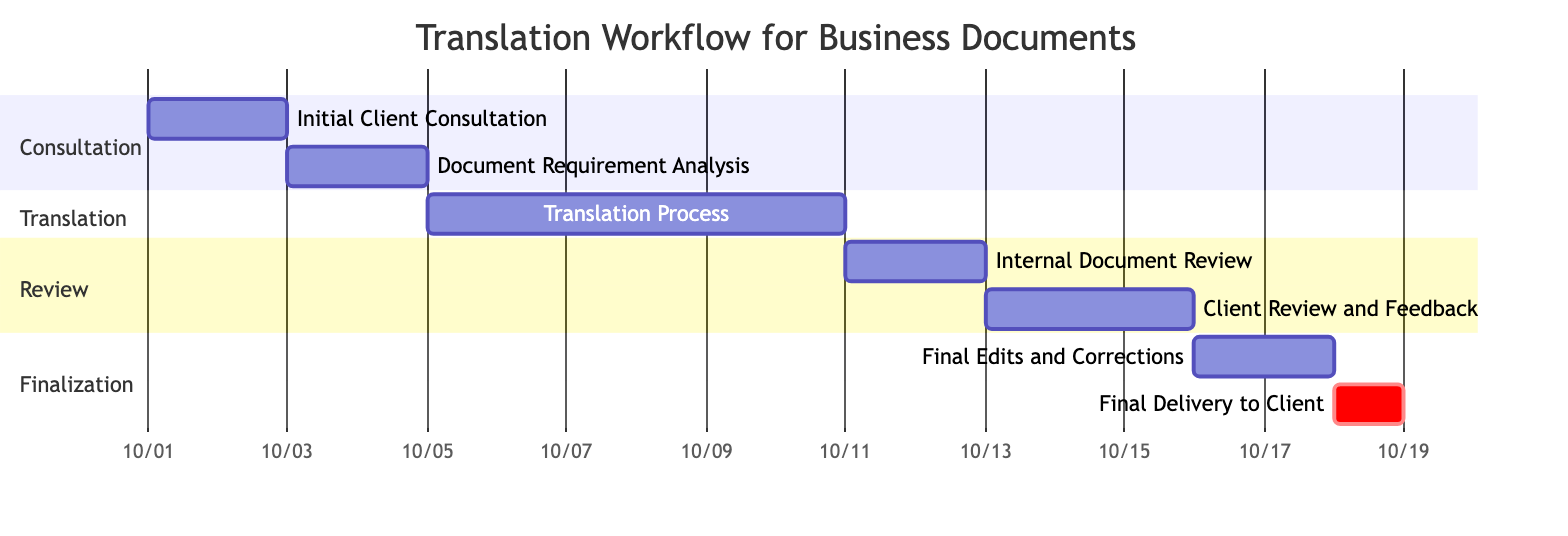What is the duration of the Translation Process? The Translation Process is indicated in the section called "Translation" and has a specified duration of 6 days.
Answer: 6 days What is the start date of the Client Review and Feedback? The Client Review and Feedback task starts on October 13, 2023, which can be found in the "Review" section of the diagram.
Answer: 2023-10-13 How many tasks are in the Finalization section? The Finalization section contains two tasks: "Final Edits and Corrections" and "Final Delivery to Client," thus totaling two tasks.
Answer: 2 Which task occurs immediately after Internal Document Review? Following the Internal Document Review, the next task is Client Review and Feedback based on the timeline sequence provided in the Gantt chart.
Answer: Client Review and Feedback What is the total duration of the Consultation phase? The Consultation phase includes two tasks: Initial Client Consultation (2 days) and Document Requirement Analysis (2 days), leading to a total duration of 4 days when summed together.
Answer: 4 days Which task is marked as critical in the Gantt chart? The task that is marked as critical is the Final Delivery to Client, indicated by the "crit" label next to it in the Gantt chart's representation.
Answer: Final Delivery to Client When does the Internal Document Review task start? The Internal Document Review task starts on October 11, 2023, as shown in the date information in the "Review" section of the diagram.
Answer: 2023-10-11 What is the end date of the Final Edits and Corrections? The Final Edits and Corrections task ends on October 17, 2023, according to the timeline provided in the Gantt chart.
Answer: 2023-10-17 